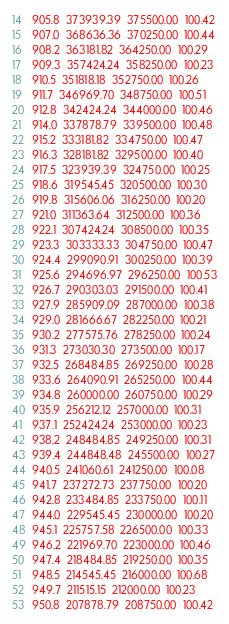Convert code to text. <code><loc_0><loc_0><loc_500><loc_500><_SML_>905.8  373939.39  375500.00  100.42
907.0  368636.36  370250.00  100.44
908.2  363181.82  364250.00  100.29
909.3  357424.24  358250.00  100.23
910.5  351818.18  352750.00  100.26
911.7  346969.70  348750.00  100.51
912.8  342424.24  344000.00  100.46
914.0  337878.79  339500.00  100.48
915.2  333181.82  334750.00  100.47
916.3  328181.82  329500.00  100.40
917.5  323939.39  324750.00  100.25
918.6  319545.45  320500.00  100.30
919.8  315606.06  316250.00  100.20
921.0  311363.64  312500.00  100.36
922.1  307424.24  308500.00  100.35
923.3  303333.33  304750.00  100.47
924.4  299090.91  300250.00  100.39
925.6  294696.97  296250.00  100.53
926.7  290303.03  291500.00  100.41
927.9  285909.09  287000.00  100.38
929.0  281666.67  282250.00  100.21
930.2  277575.76  278250.00  100.24
931.3  273030.30  273500.00  100.17
932.5  268484.85  269250.00  100.28
933.6  264090.91  265250.00  100.44
934.8  260000.00  260750.00  100.29
935.9  256212.12  257000.00  100.31
937.1  252424.24  253000.00  100.23
938.2  248484.85  249250.00  100.31
939.4  244848.48  245500.00  100.27
940.5  241060.61  241250.00  100.08
941.7  237272.73  237750.00  100.20
942.8  233484.85  233750.00  100.11
944.0  229545.45  230000.00  100.20
945.1  225757.58  226500.00  100.33
946.2  221969.70  223000.00  100.46
947.4  218484.85  219250.00  100.35
948.5  214545.45  216000.00  100.68
949.7  211515.15  212000.00  100.23
950.8  207878.79  208750.00  100.42</code> 